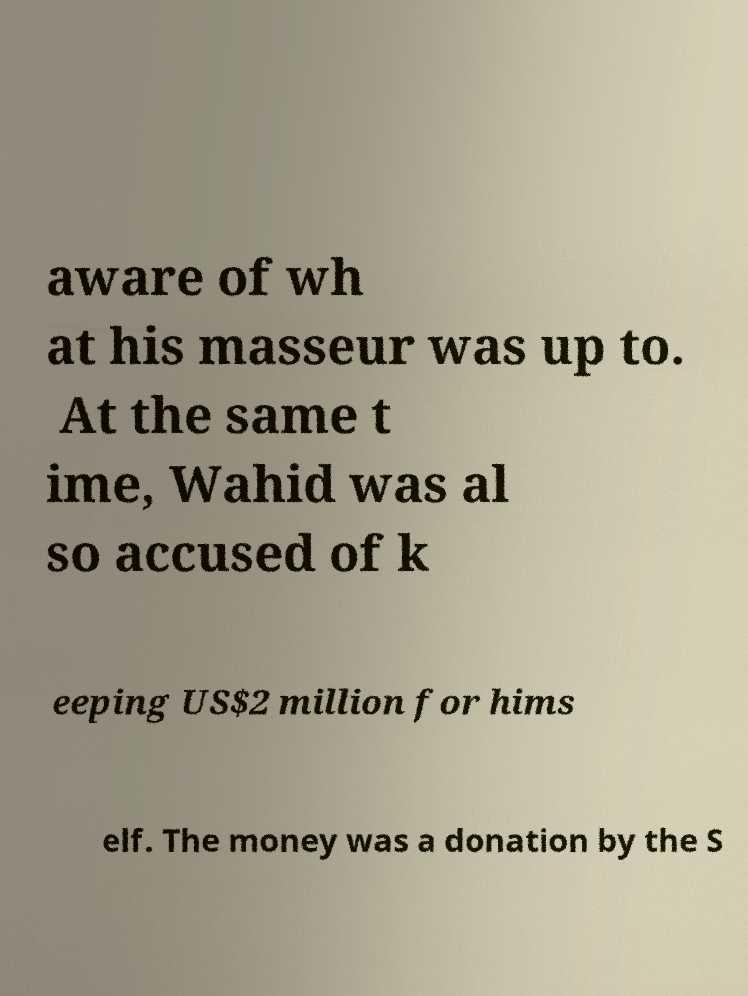Can you read and provide the text displayed in the image?This photo seems to have some interesting text. Can you extract and type it out for me? aware of wh at his masseur was up to. At the same t ime, Wahid was al so accused of k eeping US$2 million for hims elf. The money was a donation by the S 